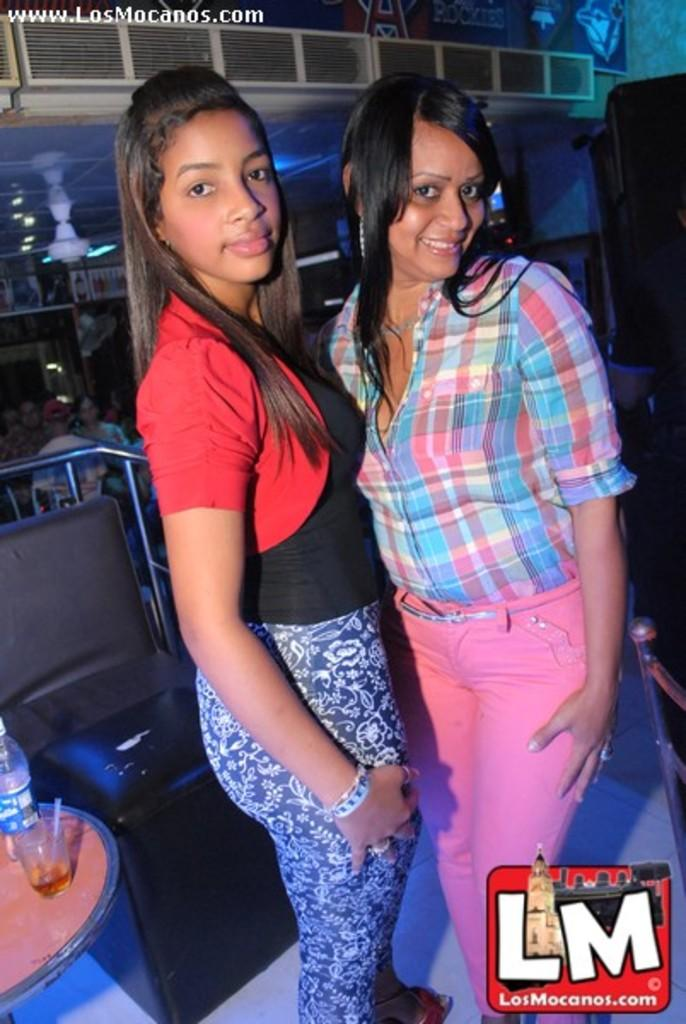How many women are present in the image? There are two women in the image. What are the women doing in the image? The women are taking a picture. What objects can be seen on the table in the image? There is a glass and a bottle on the table. Can you describe the background of the image? There are people sitting on chairs in the background. What type of umbrella is being used by the women in the image? There is no umbrella present in the image. What song are the women singing in the image? There is no indication in the image that the women are singing a song. 